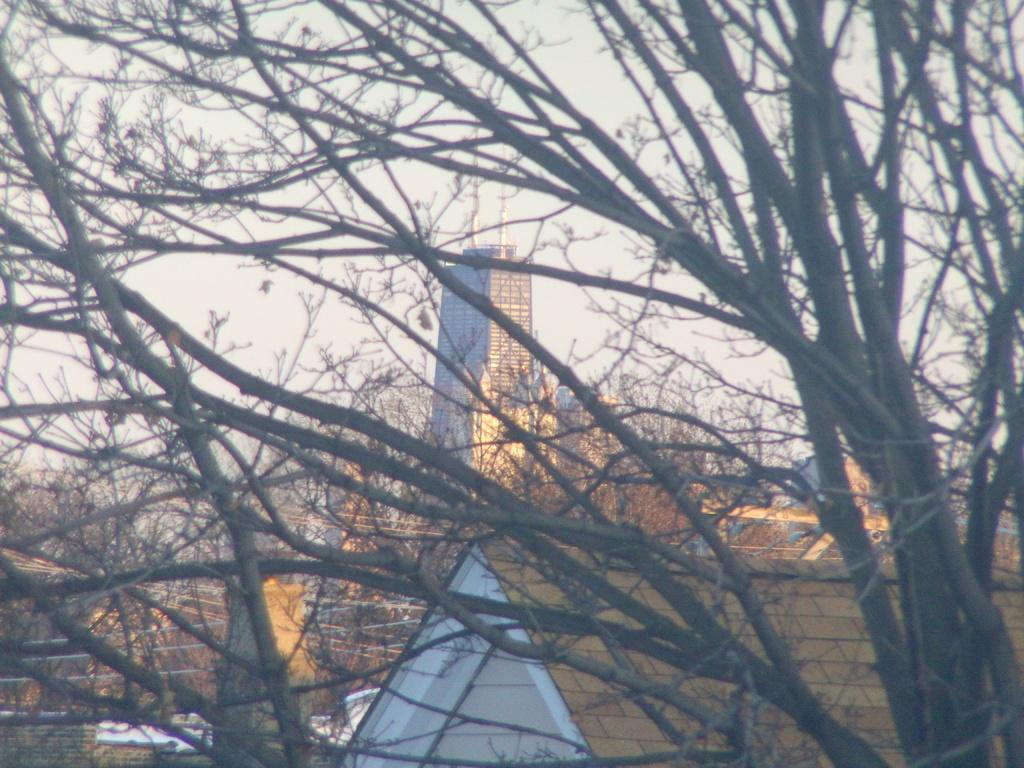What is in the foreground of the image? There are tree branches in the foreground of the image. What is visible in the background of the image? There is a building in the background of the image. What type of structure can be seen in the image? There is a fencing in the image. What list is the father reading to the parent in the image? There is no list, father, or parent present in the image. What type of parent is depicted in the image? There is no parent depicted in the image. 